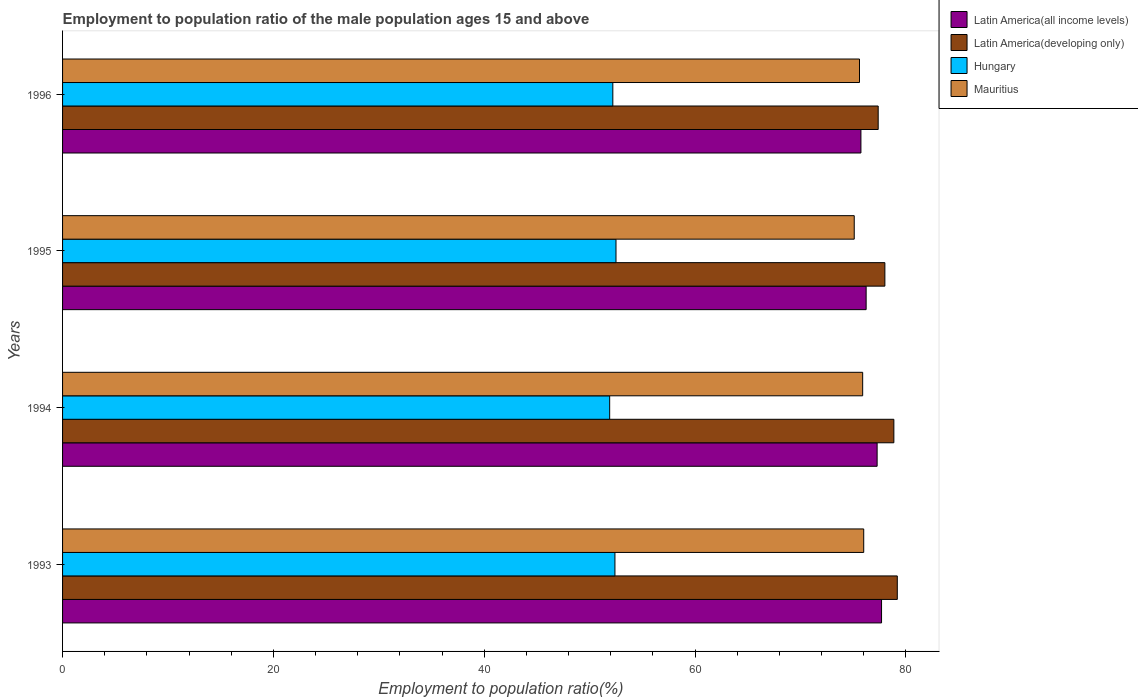How many groups of bars are there?
Your response must be concise. 4. Are the number of bars on each tick of the Y-axis equal?
Make the answer very short. Yes. How many bars are there on the 2nd tick from the top?
Give a very brief answer. 4. In how many cases, is the number of bars for a given year not equal to the number of legend labels?
Provide a succinct answer. 0. Across all years, what is the maximum employment to population ratio in Latin America(all income levels)?
Keep it short and to the point. 77.69. Across all years, what is the minimum employment to population ratio in Latin America(developing only)?
Offer a terse response. 77.37. In which year was the employment to population ratio in Hungary maximum?
Make the answer very short. 1995. What is the total employment to population ratio in Latin America(all income levels) in the graph?
Your answer should be compact. 306.93. What is the difference between the employment to population ratio in Hungary in 1994 and that in 1995?
Give a very brief answer. -0.6. What is the difference between the employment to population ratio in Latin America(all income levels) in 1993 and the employment to population ratio in Mauritius in 1995?
Your response must be concise. 2.59. What is the average employment to population ratio in Hungary per year?
Make the answer very short. 52.25. In the year 1993, what is the difference between the employment to population ratio in Mauritius and employment to population ratio in Latin America(developing only)?
Make the answer very short. -3.19. What is the ratio of the employment to population ratio in Hungary in 1995 to that in 1996?
Your answer should be very brief. 1.01. Is the employment to population ratio in Latin America(developing only) in 1994 less than that in 1996?
Your answer should be very brief. No. Is the difference between the employment to population ratio in Mauritius in 1994 and 1995 greater than the difference between the employment to population ratio in Latin America(developing only) in 1994 and 1995?
Offer a terse response. No. What is the difference between the highest and the second highest employment to population ratio in Latin America(all income levels)?
Make the answer very short. 0.42. What is the difference between the highest and the lowest employment to population ratio in Mauritius?
Your answer should be very brief. 0.9. In how many years, is the employment to population ratio in Latin America(all income levels) greater than the average employment to population ratio in Latin America(all income levels) taken over all years?
Your answer should be very brief. 2. What does the 4th bar from the top in 1993 represents?
Offer a very short reply. Latin America(all income levels). What does the 3rd bar from the bottom in 1993 represents?
Keep it short and to the point. Hungary. How many years are there in the graph?
Ensure brevity in your answer.  4. Are the values on the major ticks of X-axis written in scientific E-notation?
Provide a short and direct response. No. Does the graph contain any zero values?
Your response must be concise. No. Does the graph contain grids?
Offer a very short reply. No. Where does the legend appear in the graph?
Give a very brief answer. Top right. How are the legend labels stacked?
Offer a terse response. Vertical. What is the title of the graph?
Give a very brief answer. Employment to population ratio of the male population ages 15 and above. What is the label or title of the Y-axis?
Your response must be concise. Years. What is the Employment to population ratio(%) in Latin America(all income levels) in 1993?
Provide a short and direct response. 77.69. What is the Employment to population ratio(%) of Latin America(developing only) in 1993?
Give a very brief answer. 79.19. What is the Employment to population ratio(%) in Hungary in 1993?
Make the answer very short. 52.4. What is the Employment to population ratio(%) of Mauritius in 1993?
Provide a short and direct response. 76. What is the Employment to population ratio(%) of Latin America(all income levels) in 1994?
Provide a succinct answer. 77.27. What is the Employment to population ratio(%) in Latin America(developing only) in 1994?
Ensure brevity in your answer.  78.86. What is the Employment to population ratio(%) in Hungary in 1994?
Your response must be concise. 51.9. What is the Employment to population ratio(%) in Mauritius in 1994?
Ensure brevity in your answer.  75.9. What is the Employment to population ratio(%) of Latin America(all income levels) in 1995?
Provide a succinct answer. 76.23. What is the Employment to population ratio(%) in Latin America(developing only) in 1995?
Offer a very short reply. 78.01. What is the Employment to population ratio(%) in Hungary in 1995?
Give a very brief answer. 52.5. What is the Employment to population ratio(%) of Mauritius in 1995?
Offer a terse response. 75.1. What is the Employment to population ratio(%) in Latin America(all income levels) in 1996?
Your response must be concise. 75.73. What is the Employment to population ratio(%) of Latin America(developing only) in 1996?
Your response must be concise. 77.37. What is the Employment to population ratio(%) in Hungary in 1996?
Keep it short and to the point. 52.2. What is the Employment to population ratio(%) of Mauritius in 1996?
Provide a succinct answer. 75.6. Across all years, what is the maximum Employment to population ratio(%) of Latin America(all income levels)?
Your response must be concise. 77.69. Across all years, what is the maximum Employment to population ratio(%) in Latin America(developing only)?
Provide a short and direct response. 79.19. Across all years, what is the maximum Employment to population ratio(%) in Hungary?
Provide a succinct answer. 52.5. Across all years, what is the maximum Employment to population ratio(%) of Mauritius?
Ensure brevity in your answer.  76. Across all years, what is the minimum Employment to population ratio(%) of Latin America(all income levels)?
Provide a succinct answer. 75.73. Across all years, what is the minimum Employment to population ratio(%) in Latin America(developing only)?
Ensure brevity in your answer.  77.37. Across all years, what is the minimum Employment to population ratio(%) in Hungary?
Make the answer very short. 51.9. Across all years, what is the minimum Employment to population ratio(%) in Mauritius?
Your answer should be compact. 75.1. What is the total Employment to population ratio(%) in Latin America(all income levels) in the graph?
Provide a short and direct response. 306.93. What is the total Employment to population ratio(%) of Latin America(developing only) in the graph?
Offer a very short reply. 313.42. What is the total Employment to population ratio(%) of Hungary in the graph?
Offer a terse response. 209. What is the total Employment to population ratio(%) of Mauritius in the graph?
Your answer should be very brief. 302.6. What is the difference between the Employment to population ratio(%) in Latin America(all income levels) in 1993 and that in 1994?
Your answer should be very brief. 0.42. What is the difference between the Employment to population ratio(%) in Latin America(developing only) in 1993 and that in 1994?
Ensure brevity in your answer.  0.33. What is the difference between the Employment to population ratio(%) of Latin America(all income levels) in 1993 and that in 1995?
Offer a terse response. 1.46. What is the difference between the Employment to population ratio(%) in Latin America(developing only) in 1993 and that in 1995?
Ensure brevity in your answer.  1.18. What is the difference between the Employment to population ratio(%) of Hungary in 1993 and that in 1995?
Your response must be concise. -0.1. What is the difference between the Employment to population ratio(%) in Mauritius in 1993 and that in 1995?
Provide a short and direct response. 0.9. What is the difference between the Employment to population ratio(%) of Latin America(all income levels) in 1993 and that in 1996?
Your response must be concise. 1.96. What is the difference between the Employment to population ratio(%) of Latin America(developing only) in 1993 and that in 1996?
Your answer should be very brief. 1.81. What is the difference between the Employment to population ratio(%) in Hungary in 1993 and that in 1996?
Provide a succinct answer. 0.2. What is the difference between the Employment to population ratio(%) of Latin America(all income levels) in 1994 and that in 1995?
Your answer should be very brief. 1.04. What is the difference between the Employment to population ratio(%) in Latin America(developing only) in 1994 and that in 1995?
Ensure brevity in your answer.  0.85. What is the difference between the Employment to population ratio(%) of Hungary in 1994 and that in 1995?
Provide a succinct answer. -0.6. What is the difference between the Employment to population ratio(%) of Mauritius in 1994 and that in 1995?
Provide a succinct answer. 0.8. What is the difference between the Employment to population ratio(%) of Latin America(all income levels) in 1994 and that in 1996?
Your answer should be very brief. 1.54. What is the difference between the Employment to population ratio(%) of Latin America(developing only) in 1994 and that in 1996?
Your response must be concise. 1.49. What is the difference between the Employment to population ratio(%) in Latin America(all income levels) in 1995 and that in 1996?
Keep it short and to the point. 0.49. What is the difference between the Employment to population ratio(%) in Latin America(developing only) in 1995 and that in 1996?
Give a very brief answer. 0.63. What is the difference between the Employment to population ratio(%) in Hungary in 1995 and that in 1996?
Give a very brief answer. 0.3. What is the difference between the Employment to population ratio(%) in Mauritius in 1995 and that in 1996?
Provide a short and direct response. -0.5. What is the difference between the Employment to population ratio(%) in Latin America(all income levels) in 1993 and the Employment to population ratio(%) in Latin America(developing only) in 1994?
Offer a terse response. -1.17. What is the difference between the Employment to population ratio(%) of Latin America(all income levels) in 1993 and the Employment to population ratio(%) of Hungary in 1994?
Make the answer very short. 25.79. What is the difference between the Employment to population ratio(%) in Latin America(all income levels) in 1993 and the Employment to population ratio(%) in Mauritius in 1994?
Give a very brief answer. 1.79. What is the difference between the Employment to population ratio(%) of Latin America(developing only) in 1993 and the Employment to population ratio(%) of Hungary in 1994?
Ensure brevity in your answer.  27.29. What is the difference between the Employment to population ratio(%) in Latin America(developing only) in 1993 and the Employment to population ratio(%) in Mauritius in 1994?
Provide a succinct answer. 3.29. What is the difference between the Employment to population ratio(%) in Hungary in 1993 and the Employment to population ratio(%) in Mauritius in 1994?
Offer a terse response. -23.5. What is the difference between the Employment to population ratio(%) in Latin America(all income levels) in 1993 and the Employment to population ratio(%) in Latin America(developing only) in 1995?
Keep it short and to the point. -0.32. What is the difference between the Employment to population ratio(%) of Latin America(all income levels) in 1993 and the Employment to population ratio(%) of Hungary in 1995?
Your answer should be compact. 25.19. What is the difference between the Employment to population ratio(%) of Latin America(all income levels) in 1993 and the Employment to population ratio(%) of Mauritius in 1995?
Make the answer very short. 2.59. What is the difference between the Employment to population ratio(%) of Latin America(developing only) in 1993 and the Employment to population ratio(%) of Hungary in 1995?
Provide a succinct answer. 26.69. What is the difference between the Employment to population ratio(%) in Latin America(developing only) in 1993 and the Employment to population ratio(%) in Mauritius in 1995?
Your answer should be compact. 4.09. What is the difference between the Employment to population ratio(%) in Hungary in 1993 and the Employment to population ratio(%) in Mauritius in 1995?
Provide a succinct answer. -22.7. What is the difference between the Employment to population ratio(%) of Latin America(all income levels) in 1993 and the Employment to population ratio(%) of Latin America(developing only) in 1996?
Keep it short and to the point. 0.32. What is the difference between the Employment to population ratio(%) in Latin America(all income levels) in 1993 and the Employment to population ratio(%) in Hungary in 1996?
Offer a very short reply. 25.49. What is the difference between the Employment to population ratio(%) in Latin America(all income levels) in 1993 and the Employment to population ratio(%) in Mauritius in 1996?
Ensure brevity in your answer.  2.09. What is the difference between the Employment to population ratio(%) of Latin America(developing only) in 1993 and the Employment to population ratio(%) of Hungary in 1996?
Offer a terse response. 26.99. What is the difference between the Employment to population ratio(%) of Latin America(developing only) in 1993 and the Employment to population ratio(%) of Mauritius in 1996?
Give a very brief answer. 3.59. What is the difference between the Employment to population ratio(%) of Hungary in 1993 and the Employment to population ratio(%) of Mauritius in 1996?
Offer a terse response. -23.2. What is the difference between the Employment to population ratio(%) in Latin America(all income levels) in 1994 and the Employment to population ratio(%) in Latin America(developing only) in 1995?
Offer a very short reply. -0.73. What is the difference between the Employment to population ratio(%) of Latin America(all income levels) in 1994 and the Employment to population ratio(%) of Hungary in 1995?
Make the answer very short. 24.77. What is the difference between the Employment to population ratio(%) of Latin America(all income levels) in 1994 and the Employment to population ratio(%) of Mauritius in 1995?
Offer a terse response. 2.17. What is the difference between the Employment to population ratio(%) of Latin America(developing only) in 1994 and the Employment to population ratio(%) of Hungary in 1995?
Make the answer very short. 26.36. What is the difference between the Employment to population ratio(%) in Latin America(developing only) in 1994 and the Employment to population ratio(%) in Mauritius in 1995?
Offer a terse response. 3.76. What is the difference between the Employment to population ratio(%) in Hungary in 1994 and the Employment to population ratio(%) in Mauritius in 1995?
Provide a succinct answer. -23.2. What is the difference between the Employment to population ratio(%) in Latin America(all income levels) in 1994 and the Employment to population ratio(%) in Latin America(developing only) in 1996?
Give a very brief answer. -0.1. What is the difference between the Employment to population ratio(%) in Latin America(all income levels) in 1994 and the Employment to population ratio(%) in Hungary in 1996?
Provide a succinct answer. 25.07. What is the difference between the Employment to population ratio(%) of Latin America(all income levels) in 1994 and the Employment to population ratio(%) of Mauritius in 1996?
Your answer should be very brief. 1.67. What is the difference between the Employment to population ratio(%) in Latin America(developing only) in 1994 and the Employment to population ratio(%) in Hungary in 1996?
Ensure brevity in your answer.  26.66. What is the difference between the Employment to population ratio(%) of Latin America(developing only) in 1994 and the Employment to population ratio(%) of Mauritius in 1996?
Ensure brevity in your answer.  3.26. What is the difference between the Employment to population ratio(%) of Hungary in 1994 and the Employment to population ratio(%) of Mauritius in 1996?
Provide a short and direct response. -23.7. What is the difference between the Employment to population ratio(%) of Latin America(all income levels) in 1995 and the Employment to population ratio(%) of Latin America(developing only) in 1996?
Make the answer very short. -1.14. What is the difference between the Employment to population ratio(%) in Latin America(all income levels) in 1995 and the Employment to population ratio(%) in Hungary in 1996?
Provide a succinct answer. 24.03. What is the difference between the Employment to population ratio(%) of Latin America(all income levels) in 1995 and the Employment to population ratio(%) of Mauritius in 1996?
Your answer should be compact. 0.63. What is the difference between the Employment to population ratio(%) in Latin America(developing only) in 1995 and the Employment to population ratio(%) in Hungary in 1996?
Make the answer very short. 25.81. What is the difference between the Employment to population ratio(%) of Latin America(developing only) in 1995 and the Employment to population ratio(%) of Mauritius in 1996?
Your response must be concise. 2.41. What is the difference between the Employment to population ratio(%) in Hungary in 1995 and the Employment to population ratio(%) in Mauritius in 1996?
Offer a very short reply. -23.1. What is the average Employment to population ratio(%) in Latin America(all income levels) per year?
Your answer should be very brief. 76.73. What is the average Employment to population ratio(%) in Latin America(developing only) per year?
Provide a short and direct response. 78.36. What is the average Employment to population ratio(%) in Hungary per year?
Make the answer very short. 52.25. What is the average Employment to population ratio(%) of Mauritius per year?
Offer a terse response. 75.65. In the year 1993, what is the difference between the Employment to population ratio(%) of Latin America(all income levels) and Employment to population ratio(%) of Latin America(developing only)?
Give a very brief answer. -1.49. In the year 1993, what is the difference between the Employment to population ratio(%) of Latin America(all income levels) and Employment to population ratio(%) of Hungary?
Your answer should be compact. 25.29. In the year 1993, what is the difference between the Employment to population ratio(%) of Latin America(all income levels) and Employment to population ratio(%) of Mauritius?
Give a very brief answer. 1.69. In the year 1993, what is the difference between the Employment to population ratio(%) in Latin America(developing only) and Employment to population ratio(%) in Hungary?
Ensure brevity in your answer.  26.79. In the year 1993, what is the difference between the Employment to population ratio(%) in Latin America(developing only) and Employment to population ratio(%) in Mauritius?
Make the answer very short. 3.19. In the year 1993, what is the difference between the Employment to population ratio(%) of Hungary and Employment to population ratio(%) of Mauritius?
Make the answer very short. -23.6. In the year 1994, what is the difference between the Employment to population ratio(%) of Latin America(all income levels) and Employment to population ratio(%) of Latin America(developing only)?
Ensure brevity in your answer.  -1.59. In the year 1994, what is the difference between the Employment to population ratio(%) in Latin America(all income levels) and Employment to population ratio(%) in Hungary?
Offer a very short reply. 25.37. In the year 1994, what is the difference between the Employment to population ratio(%) of Latin America(all income levels) and Employment to population ratio(%) of Mauritius?
Keep it short and to the point. 1.37. In the year 1994, what is the difference between the Employment to population ratio(%) of Latin America(developing only) and Employment to population ratio(%) of Hungary?
Provide a succinct answer. 26.96. In the year 1994, what is the difference between the Employment to population ratio(%) of Latin America(developing only) and Employment to population ratio(%) of Mauritius?
Make the answer very short. 2.96. In the year 1995, what is the difference between the Employment to population ratio(%) of Latin America(all income levels) and Employment to population ratio(%) of Latin America(developing only)?
Give a very brief answer. -1.78. In the year 1995, what is the difference between the Employment to population ratio(%) in Latin America(all income levels) and Employment to population ratio(%) in Hungary?
Keep it short and to the point. 23.73. In the year 1995, what is the difference between the Employment to population ratio(%) of Latin America(all income levels) and Employment to population ratio(%) of Mauritius?
Provide a short and direct response. 1.13. In the year 1995, what is the difference between the Employment to population ratio(%) of Latin America(developing only) and Employment to population ratio(%) of Hungary?
Make the answer very short. 25.51. In the year 1995, what is the difference between the Employment to population ratio(%) of Latin America(developing only) and Employment to population ratio(%) of Mauritius?
Offer a terse response. 2.91. In the year 1995, what is the difference between the Employment to population ratio(%) in Hungary and Employment to population ratio(%) in Mauritius?
Give a very brief answer. -22.6. In the year 1996, what is the difference between the Employment to population ratio(%) in Latin America(all income levels) and Employment to population ratio(%) in Latin America(developing only)?
Your response must be concise. -1.64. In the year 1996, what is the difference between the Employment to population ratio(%) of Latin America(all income levels) and Employment to population ratio(%) of Hungary?
Your response must be concise. 23.53. In the year 1996, what is the difference between the Employment to population ratio(%) in Latin America(all income levels) and Employment to population ratio(%) in Mauritius?
Your response must be concise. 0.13. In the year 1996, what is the difference between the Employment to population ratio(%) of Latin America(developing only) and Employment to population ratio(%) of Hungary?
Provide a short and direct response. 25.17. In the year 1996, what is the difference between the Employment to population ratio(%) in Latin America(developing only) and Employment to population ratio(%) in Mauritius?
Provide a succinct answer. 1.77. In the year 1996, what is the difference between the Employment to population ratio(%) in Hungary and Employment to population ratio(%) in Mauritius?
Offer a very short reply. -23.4. What is the ratio of the Employment to population ratio(%) in Latin America(all income levels) in 1993 to that in 1994?
Keep it short and to the point. 1.01. What is the ratio of the Employment to population ratio(%) in Latin America(developing only) in 1993 to that in 1994?
Offer a very short reply. 1. What is the ratio of the Employment to population ratio(%) of Hungary in 1993 to that in 1994?
Your response must be concise. 1.01. What is the ratio of the Employment to population ratio(%) of Latin America(all income levels) in 1993 to that in 1995?
Provide a short and direct response. 1.02. What is the ratio of the Employment to population ratio(%) in Latin America(developing only) in 1993 to that in 1995?
Keep it short and to the point. 1.02. What is the ratio of the Employment to population ratio(%) in Hungary in 1993 to that in 1995?
Your response must be concise. 1. What is the ratio of the Employment to population ratio(%) in Latin America(all income levels) in 1993 to that in 1996?
Offer a terse response. 1.03. What is the ratio of the Employment to population ratio(%) of Latin America(developing only) in 1993 to that in 1996?
Provide a short and direct response. 1.02. What is the ratio of the Employment to population ratio(%) of Mauritius in 1993 to that in 1996?
Your response must be concise. 1.01. What is the ratio of the Employment to population ratio(%) of Latin America(all income levels) in 1994 to that in 1995?
Your answer should be very brief. 1.01. What is the ratio of the Employment to population ratio(%) in Latin America(developing only) in 1994 to that in 1995?
Offer a terse response. 1.01. What is the ratio of the Employment to population ratio(%) in Hungary in 1994 to that in 1995?
Provide a short and direct response. 0.99. What is the ratio of the Employment to population ratio(%) of Mauritius in 1994 to that in 1995?
Give a very brief answer. 1.01. What is the ratio of the Employment to population ratio(%) of Latin America(all income levels) in 1994 to that in 1996?
Provide a succinct answer. 1.02. What is the ratio of the Employment to population ratio(%) of Latin America(developing only) in 1994 to that in 1996?
Make the answer very short. 1.02. What is the ratio of the Employment to population ratio(%) in Hungary in 1994 to that in 1996?
Provide a succinct answer. 0.99. What is the ratio of the Employment to population ratio(%) in Mauritius in 1994 to that in 1996?
Make the answer very short. 1. What is the ratio of the Employment to population ratio(%) in Latin America(developing only) in 1995 to that in 1996?
Your answer should be very brief. 1.01. What is the ratio of the Employment to population ratio(%) in Mauritius in 1995 to that in 1996?
Keep it short and to the point. 0.99. What is the difference between the highest and the second highest Employment to population ratio(%) of Latin America(all income levels)?
Keep it short and to the point. 0.42. What is the difference between the highest and the second highest Employment to population ratio(%) of Latin America(developing only)?
Your answer should be compact. 0.33. What is the difference between the highest and the second highest Employment to population ratio(%) in Hungary?
Your response must be concise. 0.1. What is the difference between the highest and the second highest Employment to population ratio(%) in Mauritius?
Offer a terse response. 0.1. What is the difference between the highest and the lowest Employment to population ratio(%) of Latin America(all income levels)?
Give a very brief answer. 1.96. What is the difference between the highest and the lowest Employment to population ratio(%) of Latin America(developing only)?
Ensure brevity in your answer.  1.81. What is the difference between the highest and the lowest Employment to population ratio(%) in Mauritius?
Keep it short and to the point. 0.9. 